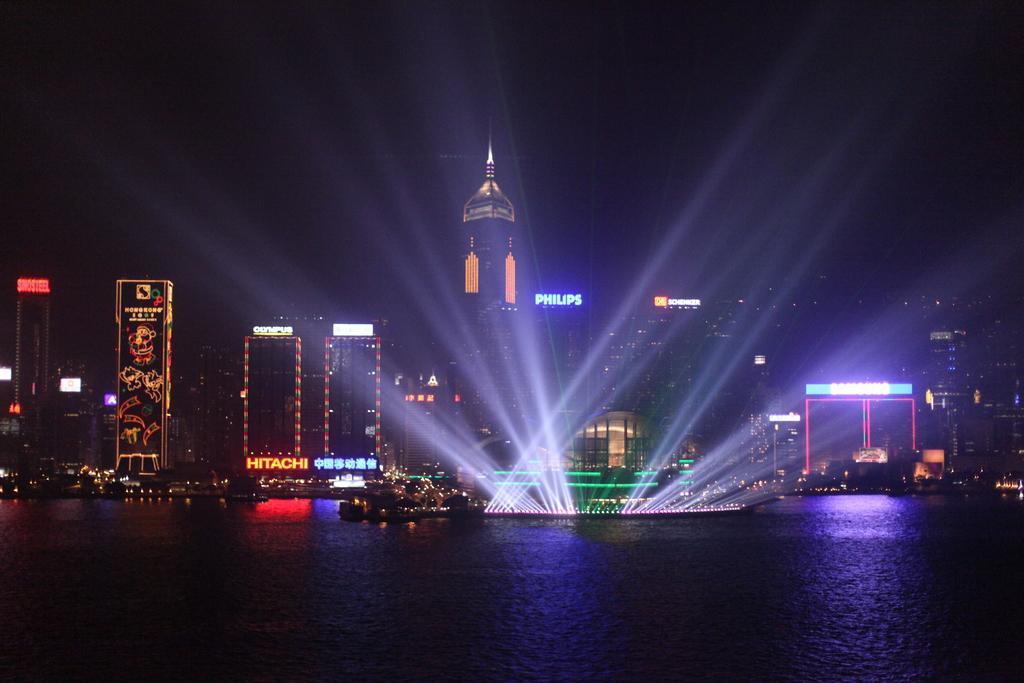Please provide a concise description of this image. At the bottom of the image there is water. Behind the water there are buildings with lights and name boards. 